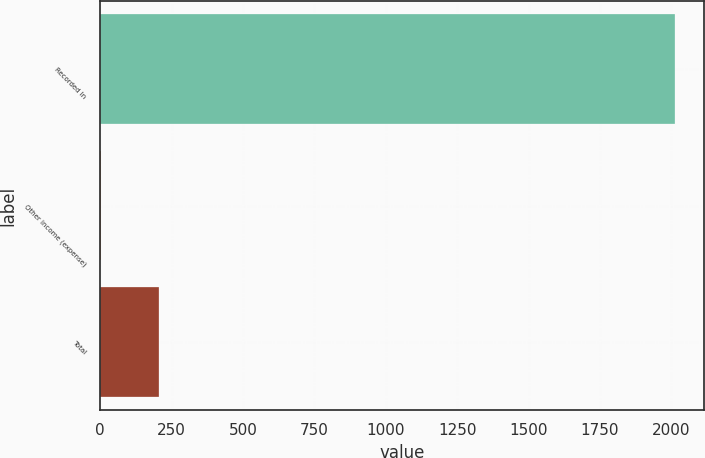<chart> <loc_0><loc_0><loc_500><loc_500><bar_chart><fcel>Recorded In<fcel>Other income (expense)<fcel>Total<nl><fcel>2013<fcel>3<fcel>204<nl></chart> 